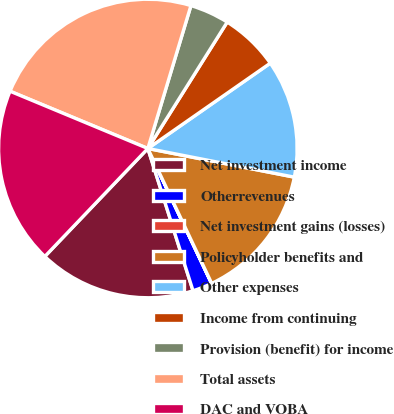<chart> <loc_0><loc_0><loc_500><loc_500><pie_chart><fcel>Net investment income<fcel>Otherrevenues<fcel>Net investment gains (losses)<fcel>Policyholder benefits and<fcel>Other expenses<fcel>Income from continuing<fcel>Provision (benefit) for income<fcel>Total assets<fcel>DAC and VOBA<nl><fcel>17.02%<fcel>2.13%<fcel>0.01%<fcel>14.89%<fcel>12.76%<fcel>6.39%<fcel>4.26%<fcel>23.39%<fcel>19.14%<nl></chart> 